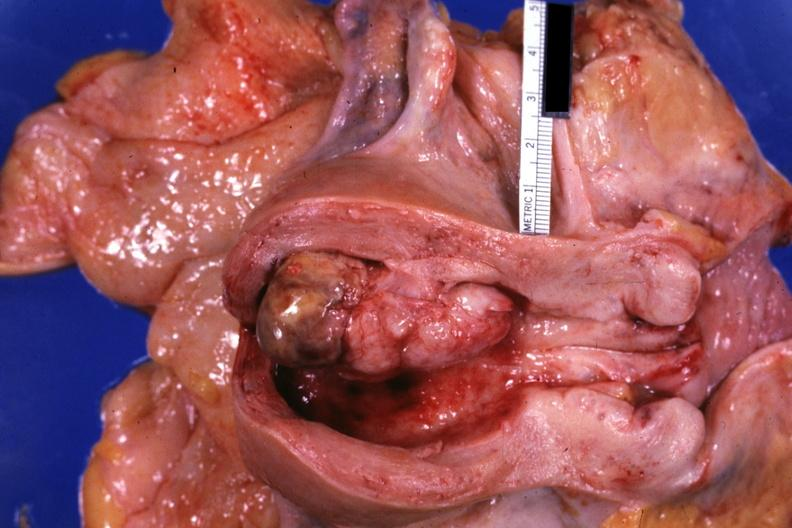where does this part belong to?
Answer the question using a single word or phrase. Female reproductive system 